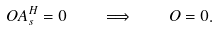<formula> <loc_0><loc_0><loc_500><loc_500>O A _ { s } ^ { H } = 0 \quad \Longrightarrow \quad O = 0 .</formula> 